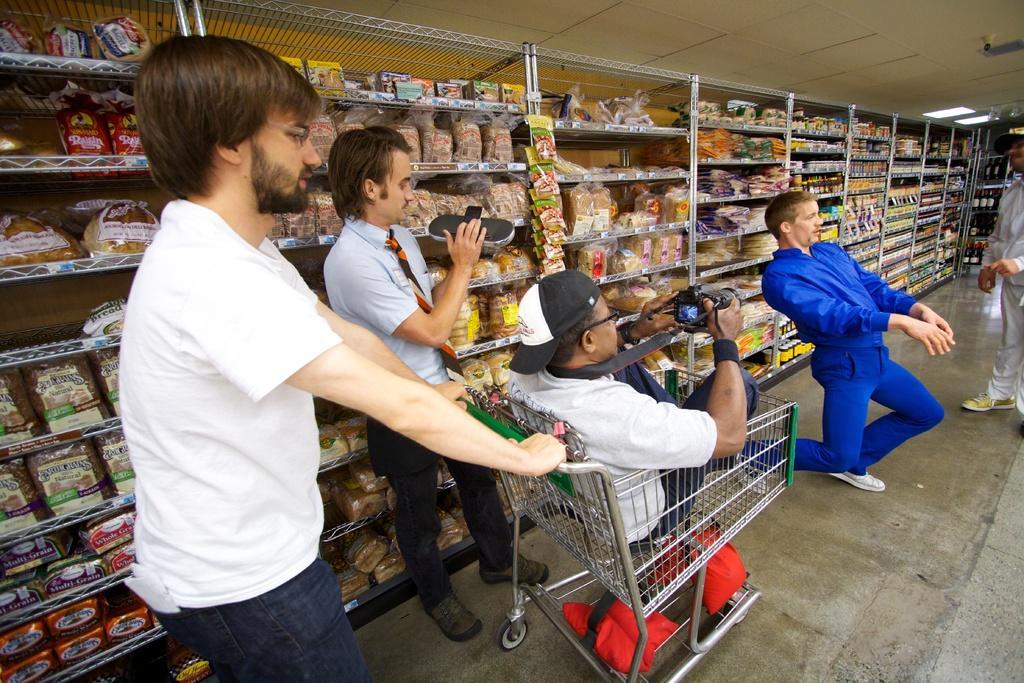In one or two sentences, can you explain what this image depicts? In this picture we can see few people. There is a man sitting inside a cart and he is holding a camera. In the background we can see racks, packets, bottles, and food items. Here we can see ceiling and lights. 